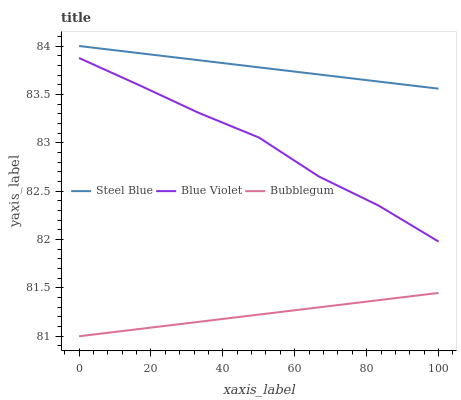Does Bubblegum have the minimum area under the curve?
Answer yes or no. Yes. Does Steel Blue have the maximum area under the curve?
Answer yes or no. Yes. Does Blue Violet have the minimum area under the curve?
Answer yes or no. No. Does Blue Violet have the maximum area under the curve?
Answer yes or no. No. Is Bubblegum the smoothest?
Answer yes or no. Yes. Is Blue Violet the roughest?
Answer yes or no. Yes. Is Steel Blue the smoothest?
Answer yes or no. No. Is Steel Blue the roughest?
Answer yes or no. No. Does Bubblegum have the lowest value?
Answer yes or no. Yes. Does Blue Violet have the lowest value?
Answer yes or no. No. Does Steel Blue have the highest value?
Answer yes or no. Yes. Does Blue Violet have the highest value?
Answer yes or no. No. Is Blue Violet less than Steel Blue?
Answer yes or no. Yes. Is Steel Blue greater than Bubblegum?
Answer yes or no. Yes. Does Blue Violet intersect Steel Blue?
Answer yes or no. No. 